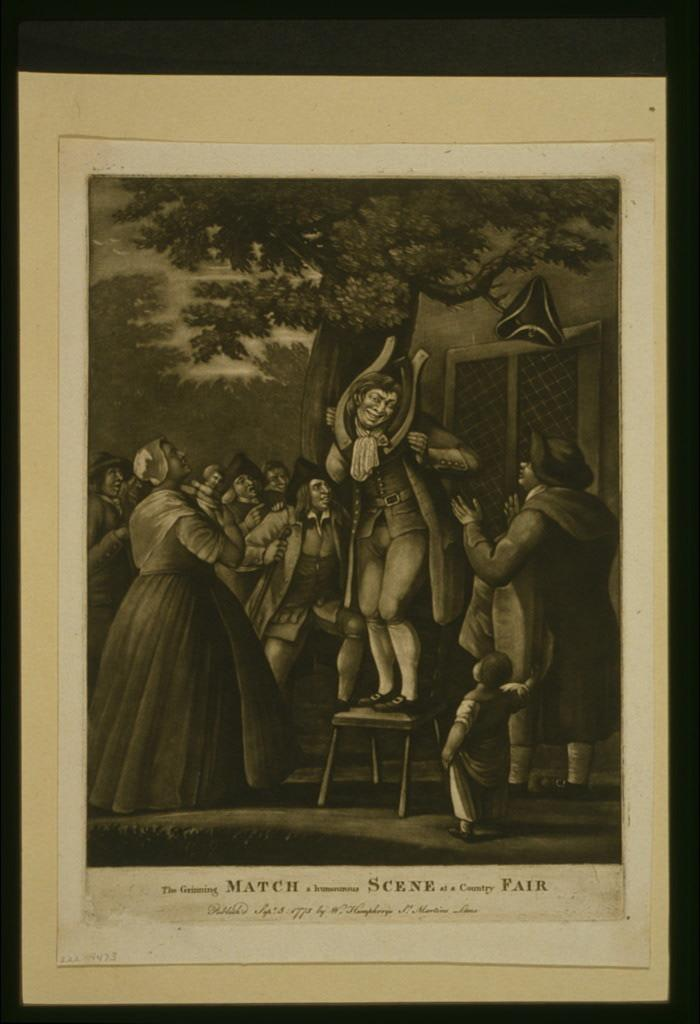What is the main subject in the center of the image? There is a poster in the center of the image. What is shown on the poster? The poster depicts people. Is there any text present in the image? Yes, there is text at the bottom of the image. What type of pies are being served at the event depicted in the poster? There is no event or pies depicted in the poster; it only shows people. How many people are attending the mass shown in the poster? There is no mass depicted in the poster; it only shows people. 